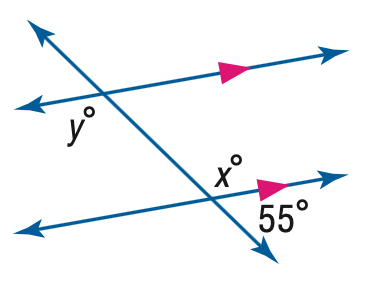Answer the mathemtical geometry problem and directly provide the correct option letter.
Question: Find the value of the variable y in the figure.
Choices: A: 55 B: 115 C: 125 D: 135 C 